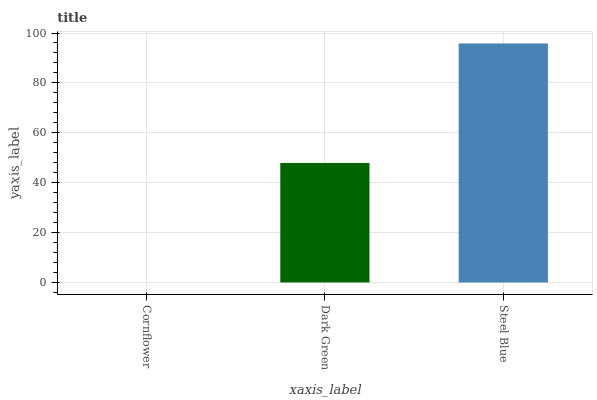Is Cornflower the minimum?
Answer yes or no. Yes. Is Steel Blue the maximum?
Answer yes or no. Yes. Is Dark Green the minimum?
Answer yes or no. No. Is Dark Green the maximum?
Answer yes or no. No. Is Dark Green greater than Cornflower?
Answer yes or no. Yes. Is Cornflower less than Dark Green?
Answer yes or no. Yes. Is Cornflower greater than Dark Green?
Answer yes or no. No. Is Dark Green less than Cornflower?
Answer yes or no. No. Is Dark Green the high median?
Answer yes or no. Yes. Is Dark Green the low median?
Answer yes or no. Yes. Is Steel Blue the high median?
Answer yes or no. No. Is Steel Blue the low median?
Answer yes or no. No. 